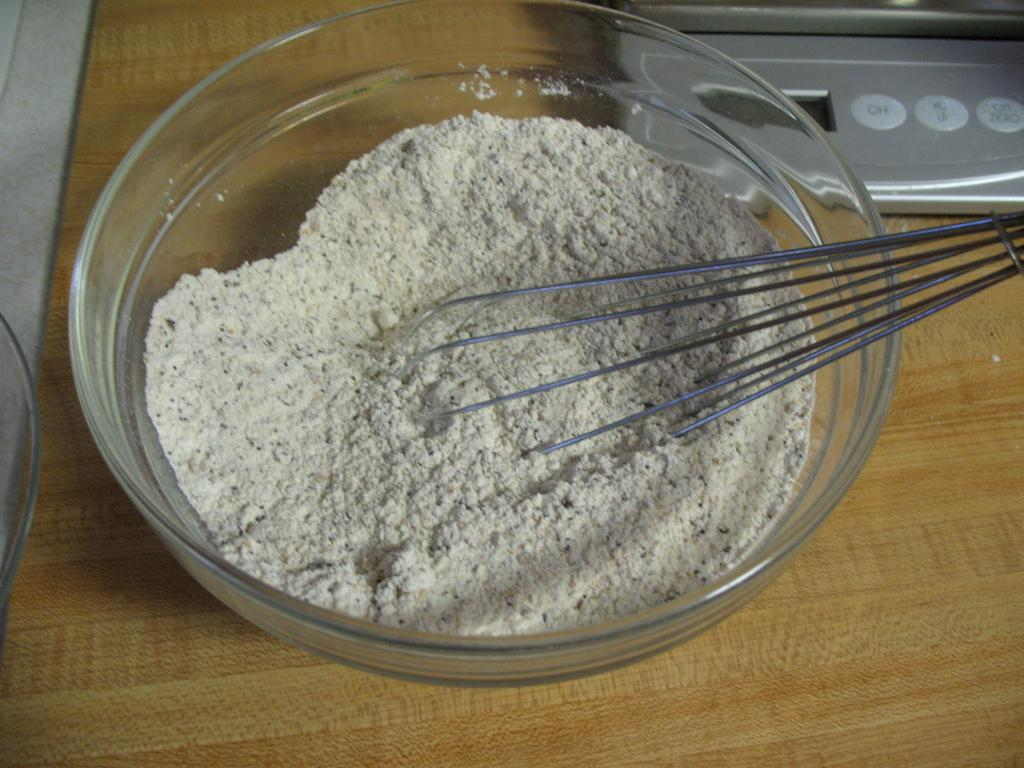What is in the glass bowl that is visible in the image? The glass bowl is full of wheat flour in the image. What utensil is present in the image? There is a whisk in the image. Where are the glass bowl and whisk located? The glass bowl and whisk are placed on a wooden table top. What type of coal is being used to attack the door in the image? There is no coal or door present in the image, and therefore no such attack can be observed. 